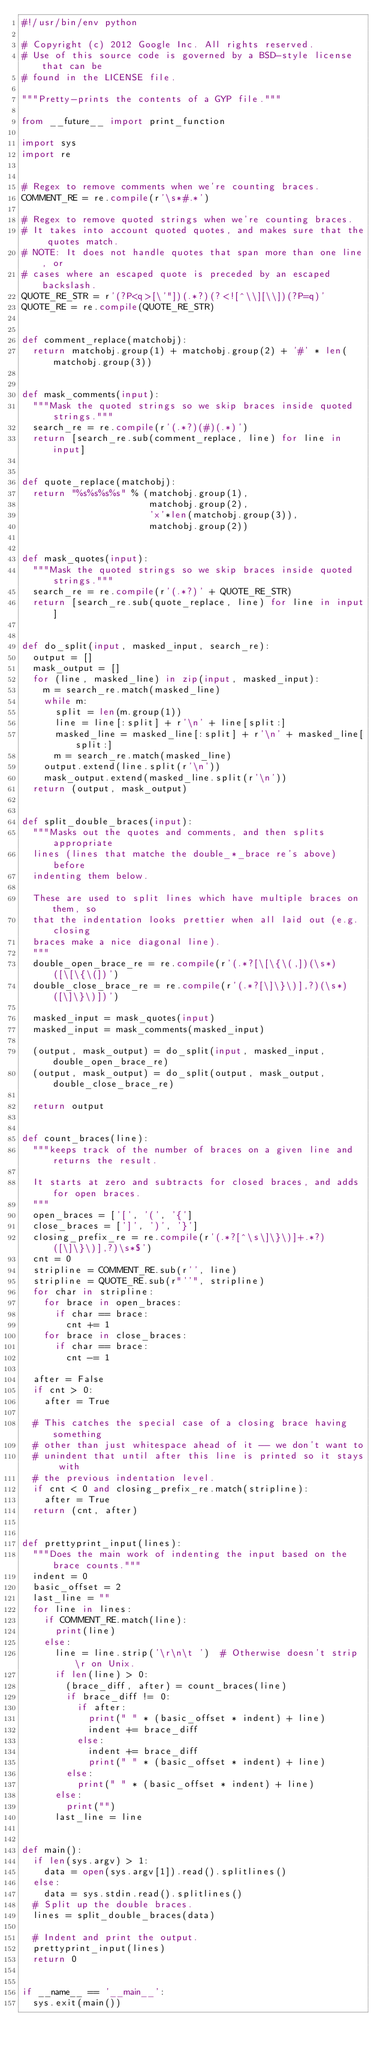Convert code to text. <code><loc_0><loc_0><loc_500><loc_500><_Python_>#!/usr/bin/env python

# Copyright (c) 2012 Google Inc. All rights reserved.
# Use of this source code is governed by a BSD-style license that can be
# found in the LICENSE file.

"""Pretty-prints the contents of a GYP file."""

from __future__ import print_function

import sys
import re


# Regex to remove comments when we're counting braces.
COMMENT_RE = re.compile(r'\s*#.*')

# Regex to remove quoted strings when we're counting braces.
# It takes into account quoted quotes, and makes sure that the quotes match.
# NOTE: It does not handle quotes that span more than one line, or
# cases where an escaped quote is preceded by an escaped backslash.
QUOTE_RE_STR = r'(?P<q>[\'"])(.*?)(?<![^\\][\\])(?P=q)'
QUOTE_RE = re.compile(QUOTE_RE_STR)


def comment_replace(matchobj):
  return matchobj.group(1) + matchobj.group(2) + '#' * len(matchobj.group(3))


def mask_comments(input):
  """Mask the quoted strings so we skip braces inside quoted strings."""
  search_re = re.compile(r'(.*?)(#)(.*)')
  return [search_re.sub(comment_replace, line) for line in input]


def quote_replace(matchobj):
  return "%s%s%s%s" % (matchobj.group(1),
                       matchobj.group(2),
                       'x'*len(matchobj.group(3)),
                       matchobj.group(2))


def mask_quotes(input):
  """Mask the quoted strings so we skip braces inside quoted strings."""
  search_re = re.compile(r'(.*?)' + QUOTE_RE_STR)
  return [search_re.sub(quote_replace, line) for line in input]


def do_split(input, masked_input, search_re):
  output = []
  mask_output = []
  for (line, masked_line) in zip(input, masked_input):
    m = search_re.match(masked_line)
    while m:
      split = len(m.group(1))
      line = line[:split] + r'\n' + line[split:]
      masked_line = masked_line[:split] + r'\n' + masked_line[split:]
      m = search_re.match(masked_line)
    output.extend(line.split(r'\n'))
    mask_output.extend(masked_line.split(r'\n'))
  return (output, mask_output)


def split_double_braces(input):
  """Masks out the quotes and comments, and then splits appropriate
  lines (lines that matche the double_*_brace re's above) before
  indenting them below.

  These are used to split lines which have multiple braces on them, so
  that the indentation looks prettier when all laid out (e.g. closing
  braces make a nice diagonal line).
  """
  double_open_brace_re = re.compile(r'(.*?[\[\{\(,])(\s*)([\[\{\(])')
  double_close_brace_re = re.compile(r'(.*?[\]\}\)],?)(\s*)([\]\}\)])')

  masked_input = mask_quotes(input)
  masked_input = mask_comments(masked_input)

  (output, mask_output) = do_split(input, masked_input, double_open_brace_re)
  (output, mask_output) = do_split(output, mask_output, double_close_brace_re)

  return output


def count_braces(line):
  """keeps track of the number of braces on a given line and returns the result.

  It starts at zero and subtracts for closed braces, and adds for open braces.
  """
  open_braces = ['[', '(', '{']
  close_braces = [']', ')', '}']
  closing_prefix_re = re.compile(r'(.*?[^\s\]\}\)]+.*?)([\]\}\)],?)\s*$')
  cnt = 0
  stripline = COMMENT_RE.sub(r'', line)
  stripline = QUOTE_RE.sub(r"''", stripline)
  for char in stripline:
    for brace in open_braces:
      if char == brace:
        cnt += 1
    for brace in close_braces:
      if char == brace:
        cnt -= 1

  after = False
  if cnt > 0:
    after = True

  # This catches the special case of a closing brace having something
  # other than just whitespace ahead of it -- we don't want to
  # unindent that until after this line is printed so it stays with
  # the previous indentation level.
  if cnt < 0 and closing_prefix_re.match(stripline):
    after = True
  return (cnt, after)


def prettyprint_input(lines):
  """Does the main work of indenting the input based on the brace counts."""
  indent = 0
  basic_offset = 2
  last_line = ""
  for line in lines:
    if COMMENT_RE.match(line):
      print(line)
    else:
      line = line.strip('\r\n\t ')  # Otherwise doesn't strip \r on Unix.
      if len(line) > 0:
        (brace_diff, after) = count_braces(line)
        if brace_diff != 0:
          if after:
            print(" " * (basic_offset * indent) + line)
            indent += brace_diff
          else:
            indent += brace_diff
            print(" " * (basic_offset * indent) + line)
        else:
          print(" " * (basic_offset * indent) + line)
      else:
        print("")
      last_line = line


def main():
  if len(sys.argv) > 1:
    data = open(sys.argv[1]).read().splitlines()
  else:
    data = sys.stdin.read().splitlines()
  # Split up the double braces.
  lines = split_double_braces(data)

  # Indent and print the output.
  prettyprint_input(lines)
  return 0


if __name__ == '__main__':
  sys.exit(main())
</code> 